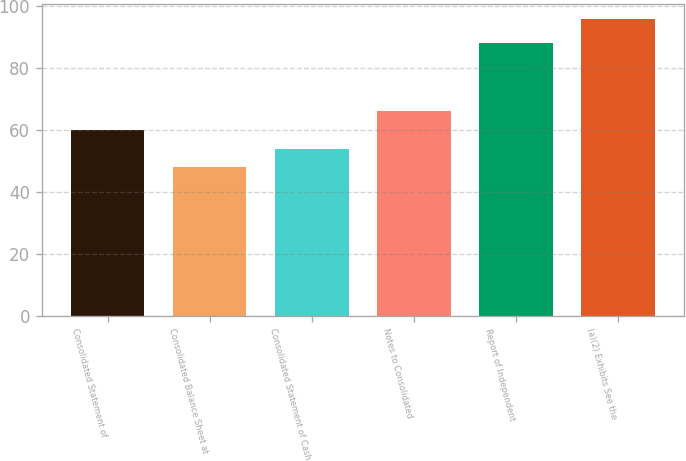Convert chart to OTSL. <chart><loc_0><loc_0><loc_500><loc_500><bar_chart><fcel>Consolidated Statement of<fcel>Consolidated Balance Sheet at<fcel>Consolidated Statement of Cash<fcel>Notes to Consolidated<fcel>Report of Independent<fcel>(a)(2) Exhibits See the<nl><fcel>60<fcel>48<fcel>54<fcel>66<fcel>88<fcel>96<nl></chart> 